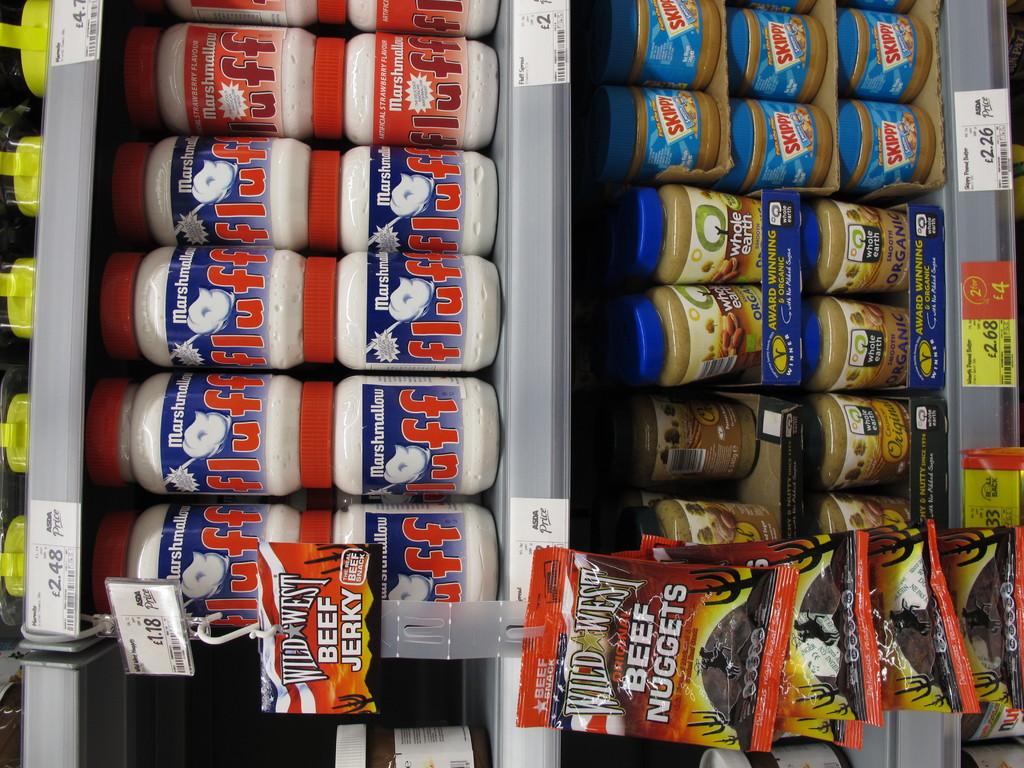What is being sold in the red bags hanging on the shelf?
Provide a short and direct response. Beef nuggets. 